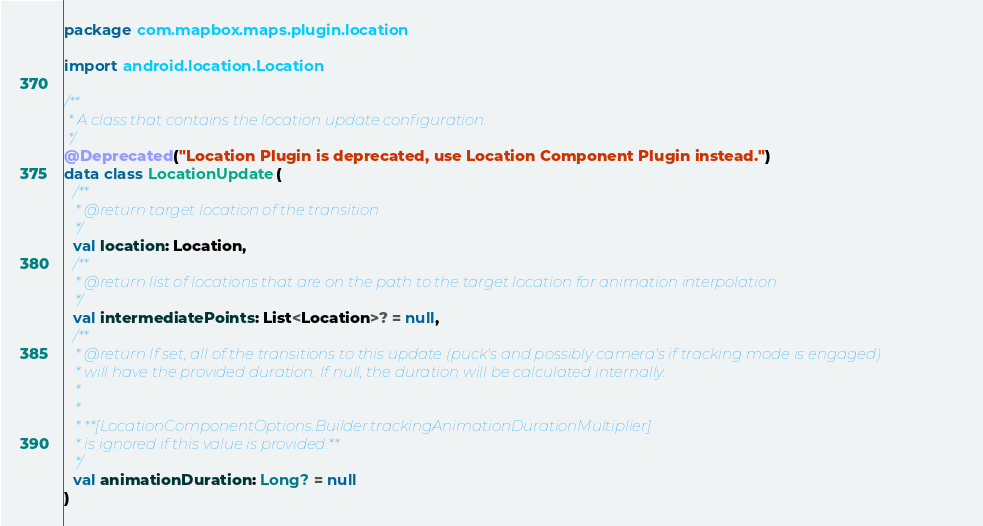Convert code to text. <code><loc_0><loc_0><loc_500><loc_500><_Kotlin_>package com.mapbox.maps.plugin.location

import android.location.Location

/**
 * A class that contains the location update configuration.
 */
@Deprecated("Location Plugin is deprecated, use Location Component Plugin instead.")
data class LocationUpdate(
  /**
   * @return target location of the transition
   */
  val location: Location,
  /**
   * @return list of locations that are on the path to the target location for animation interpolation
   */
  val intermediatePoints: List<Location>? = null,
  /**
   * @return If set, all of the transitions to this update (puck's and possibly camera's if tracking mode is engaged)
   * will have the provided duration. If null, the duration will be calculated internally.
   *
   *
   * **[LocationComponentOptions.Builder.trackingAnimationDurationMultiplier]
   * is ignored if this value is provided.**
   */
  val animationDuration: Long? = null
)</code> 